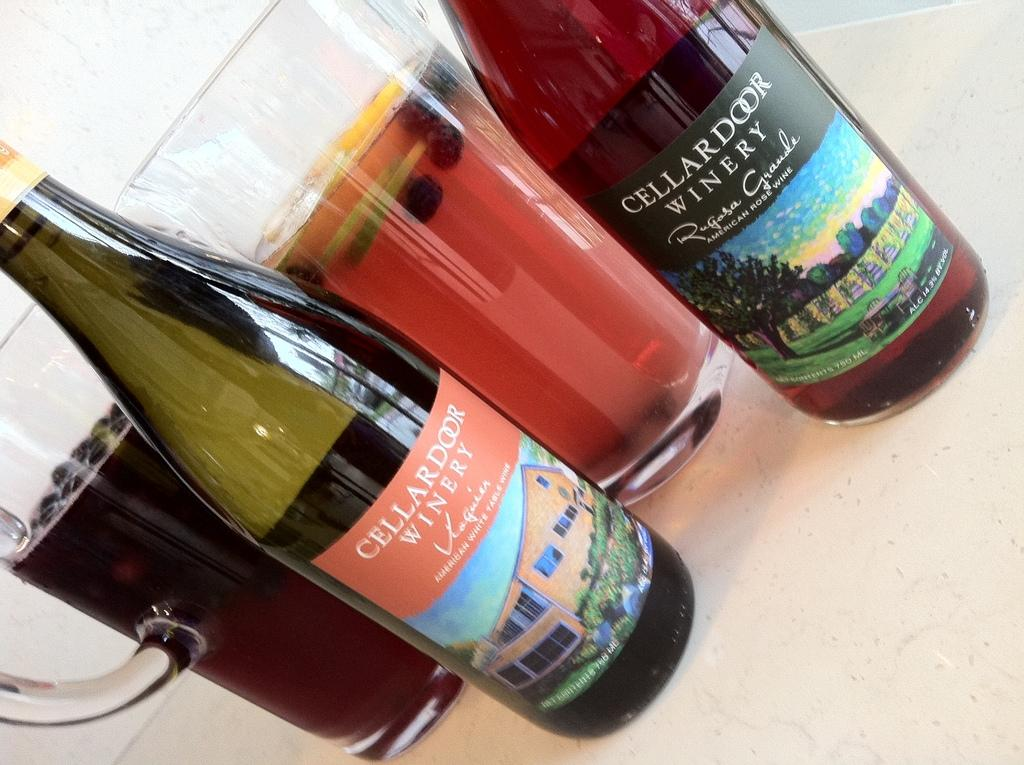Provide a one-sentence caption for the provided image. two bottles of Cellar Door Winery wine next to pitchers of cocktails. 